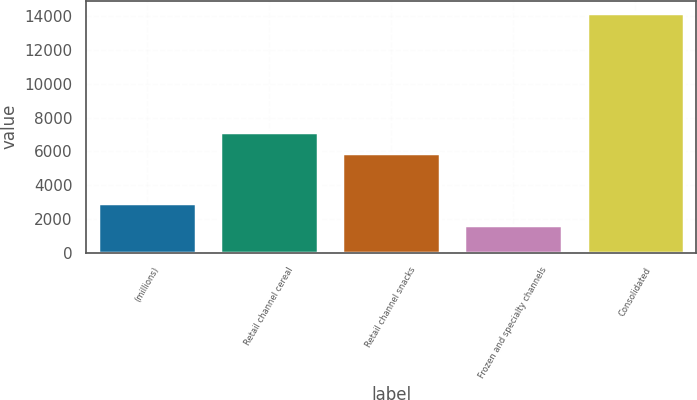<chart> <loc_0><loc_0><loc_500><loc_500><bar_chart><fcel>(millions)<fcel>Retail channel cereal<fcel>Retail channel snacks<fcel>Frozen and specialty channels<fcel>Consolidated<nl><fcel>2908.3<fcel>7145.3<fcel>5891<fcel>1654<fcel>14197<nl></chart> 